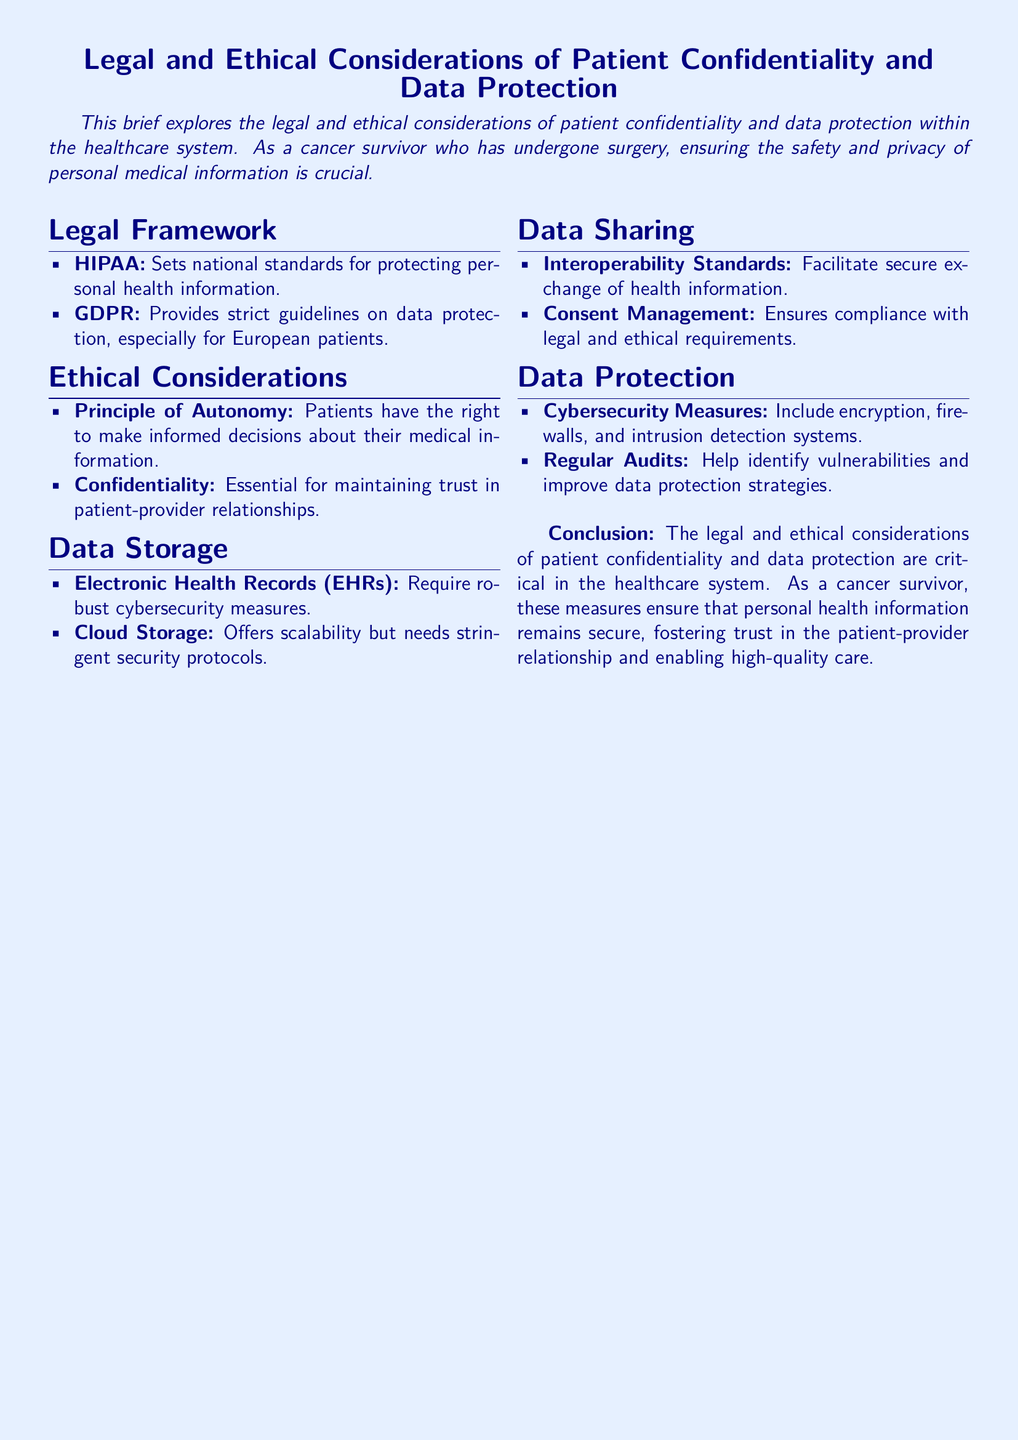What does HIPAA stand for? HIPAA is mentioned as a legal framework that sets national standards for protecting personal health information.
Answer: HIPAA What does GDPR regulate? GDPR is described as providing strict guidelines on data protection, especially for European patients.
Answer: Data protection What is a key ethical principle mentioned in the document? The document cites the Principle of Autonomy as a key ethical consideration related to patient confidentiality.
Answer: Autonomy What type of records require robust cybersecurity measures? The section on Data Storage identifies Electronic Health Records (EHRs) as needing robust cybersecurity measures.
Answer: Electronic Health Records (EHRs) What promotes secure exchange of health information? The document covers Interoperability Standards as facilitating the secure exchange of health information.
Answer: Interoperability Standards What is mentioned as a cybersecurity measure? Under Data Protection, the document lists encryption as one of the cybersecurity measures.
Answer: Encryption What type of storage offers scalability? The document mentions Cloud Storage as a type of storage that offers scalability.
Answer: Cloud Storage What is essential for maintaining trust in patient-provider relationships? The document states that confidentiality is essential for maintaining trust in these relationships.
Answer: Confidentiality What is a method used to improve data protection strategies? Regular Audits are mentioned as a method to help identify vulnerabilities and improve data protection strategies.
Answer: Regular Audits 